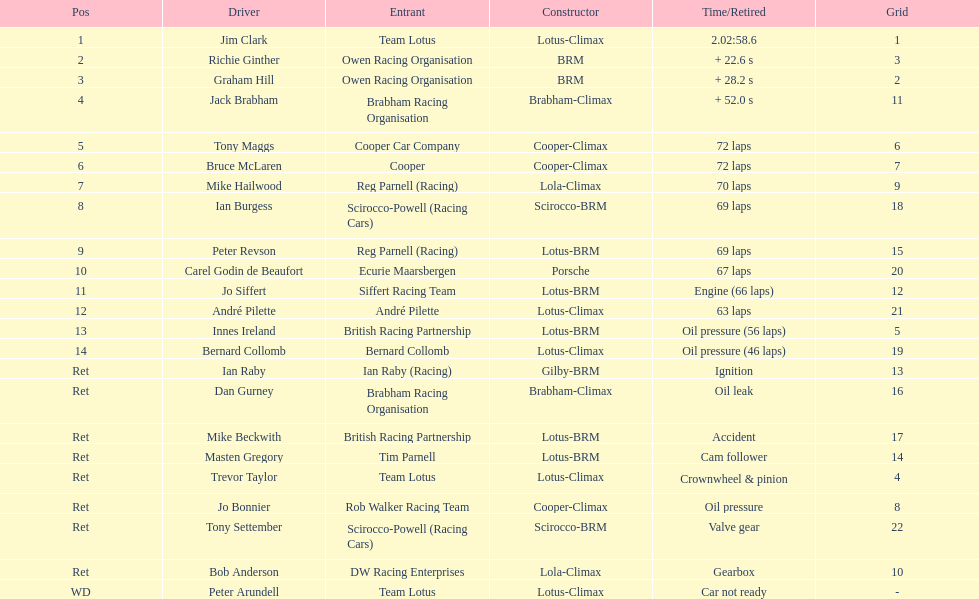What was the similar challenge that bernard collomb experienced as innes ireland? Oil pressure. 